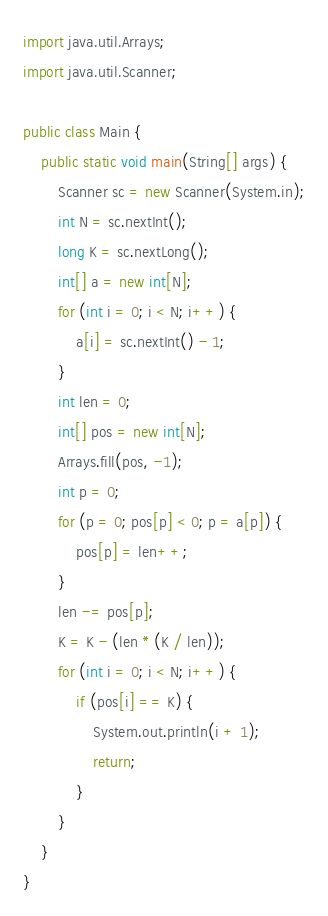<code> <loc_0><loc_0><loc_500><loc_500><_Java_>import java.util.Arrays;
import java.util.Scanner;

public class Main {
	public static void main(String[] args) {
		Scanner sc = new Scanner(System.in);
		int N = sc.nextInt();
		long K = sc.nextLong();
		int[] a = new int[N];
		for (int i = 0; i < N; i++) {
			a[i] = sc.nextInt() - 1;
		}
		int len = 0;
		int[] pos = new int[N];
		Arrays.fill(pos, -1);
		int p = 0;
		for (p = 0; pos[p] < 0; p = a[p]) {
			pos[p] = len++;
		}
		len -= pos[p];
		K = K - (len * (K / len));
		for (int i = 0; i < N; i++) {
			if (pos[i] == K) {
				System.out.println(i + 1);
				return;
			}
		}
	}
}
</code> 